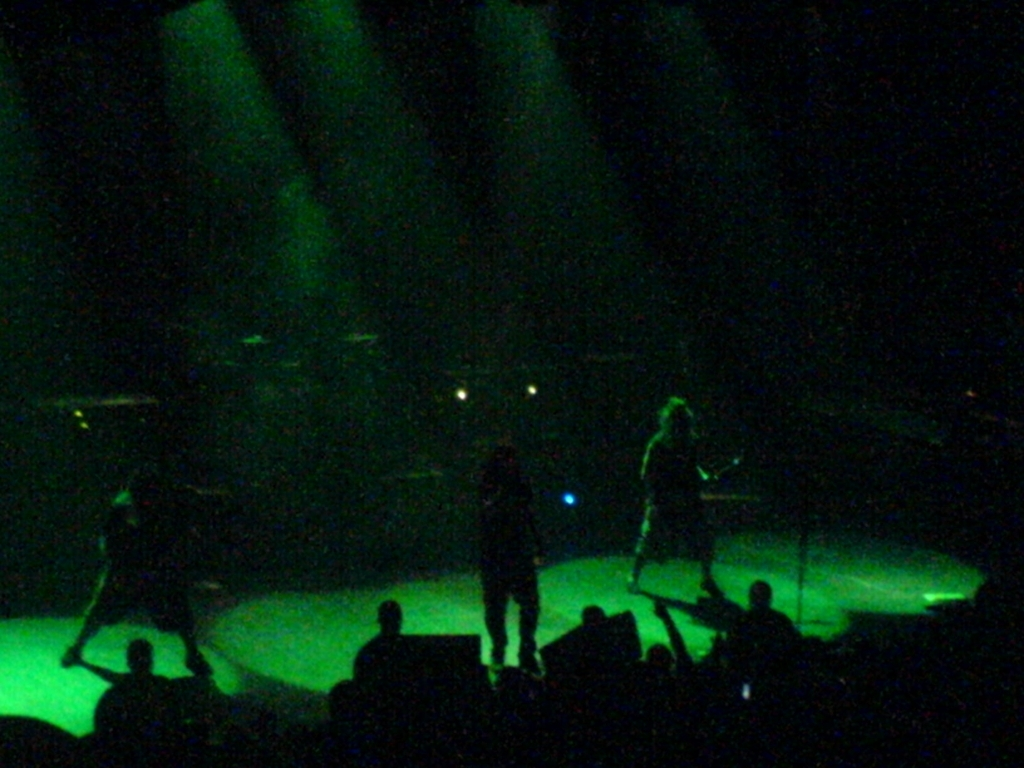Does the image have visible artifacts?
 No 